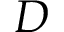<formula> <loc_0><loc_0><loc_500><loc_500>D</formula> 